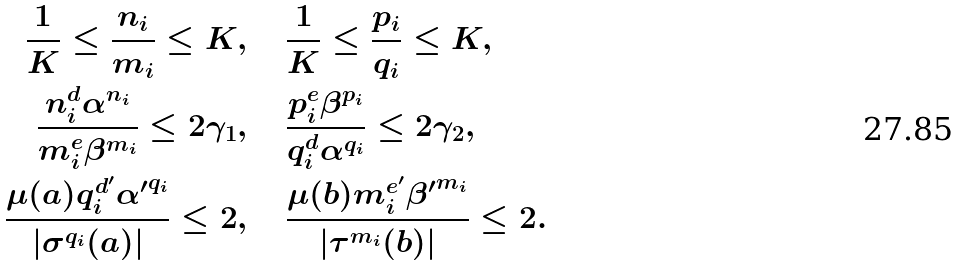<formula> <loc_0><loc_0><loc_500><loc_500>\frac { 1 } { K } \leq \frac { n _ { i } } { m _ { i } } \leq K & , \quad \frac { 1 } { K } \leq \frac { p _ { i } } { q _ { i } } \leq K , \\ \frac { n _ { i } ^ { d } \alpha ^ { n _ { i } } } { m _ { i } ^ { e } \beta ^ { m _ { i } } } \leq 2 \gamma _ { 1 } & , \quad \frac { p _ { i } ^ { e } \beta ^ { p _ { i } } } { q _ { i } ^ { d } \alpha ^ { q _ { i } } } \leq 2 \gamma _ { 2 } , \\ \frac { \mu ( a ) q _ { i } ^ { d ^ { \prime } } { \alpha ^ { \prime } } ^ { q _ { i } } } { | \sigma ^ { q _ { i } } ( a ) | } \leq 2 & , \quad \frac { \mu ( b ) m _ { i } ^ { e ^ { \prime } } { \beta ^ { \prime } } ^ { m _ { i } } } { | \tau ^ { m _ { i } } ( b ) | } \leq 2 .</formula> 